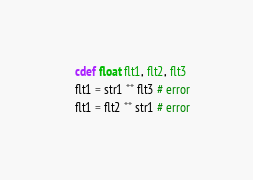<code> <loc_0><loc_0><loc_500><loc_500><_Cython_>	cdef float flt1, flt2, flt3
	flt1 = str1 ** flt3 # error
	flt1 = flt2 ** str1 # error
</code> 